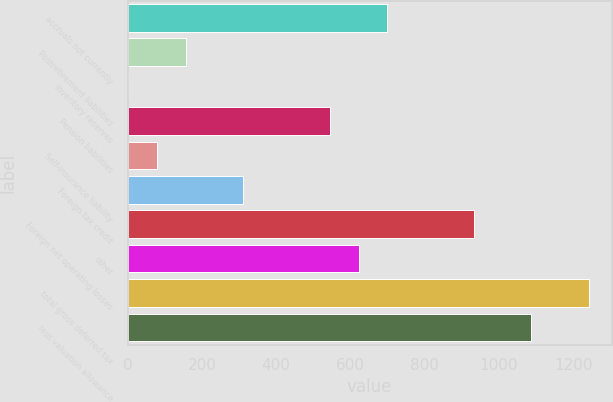Convert chart. <chart><loc_0><loc_0><loc_500><loc_500><bar_chart><fcel>accruals not currently<fcel>Postretirement liabilities<fcel>inventory reserves<fcel>Pension liabilities<fcel>Self-insurance liability<fcel>Foreign tax credit<fcel>Foreign net operating losses<fcel>other<fcel>total gross deferred tax<fcel>less valuation allowance<nl><fcel>699.25<fcel>157.1<fcel>2.2<fcel>544.35<fcel>79.65<fcel>312<fcel>931.6<fcel>621.8<fcel>1241.4<fcel>1086.5<nl></chart> 